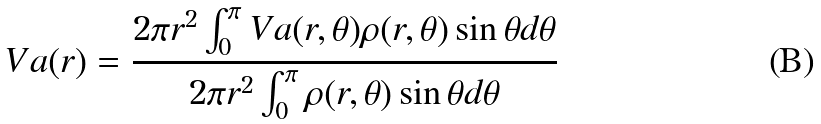Convert formula to latex. <formula><loc_0><loc_0><loc_500><loc_500>V a ( r ) = \frac { 2 \pi r ^ { 2 } \int _ { 0 } ^ { \pi } V a ( r , \theta ) \rho ( r , \theta ) \sin \theta d \theta } { 2 \pi r ^ { 2 } \int _ { 0 } ^ { \pi } \rho ( r , \theta ) \sin \theta d \theta }</formula> 